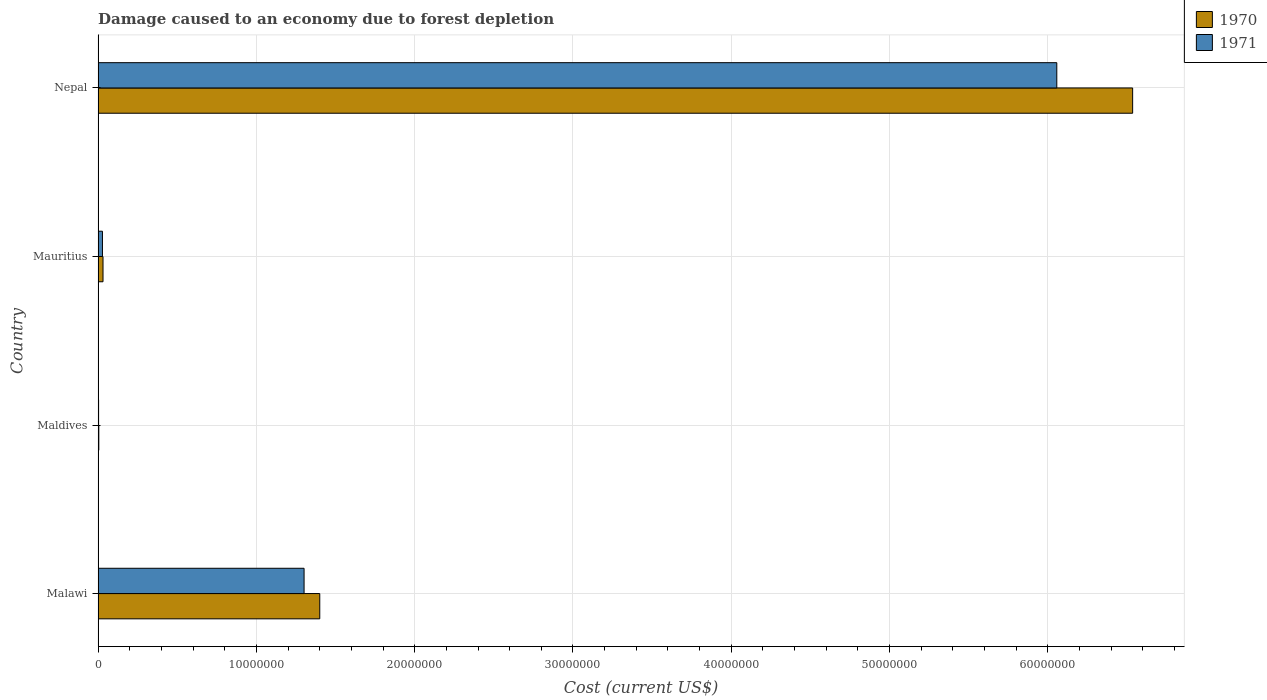How many different coloured bars are there?
Provide a short and direct response. 2. How many groups of bars are there?
Your answer should be compact. 4. Are the number of bars per tick equal to the number of legend labels?
Offer a very short reply. Yes. How many bars are there on the 4th tick from the top?
Your answer should be compact. 2. How many bars are there on the 3rd tick from the bottom?
Your answer should be very brief. 2. What is the label of the 4th group of bars from the top?
Ensure brevity in your answer.  Malawi. What is the cost of damage caused due to forest depletion in 1971 in Mauritius?
Keep it short and to the point. 2.78e+05. Across all countries, what is the maximum cost of damage caused due to forest depletion in 1971?
Offer a terse response. 6.06e+07. Across all countries, what is the minimum cost of damage caused due to forest depletion in 1971?
Your response must be concise. 3.48e+04. In which country was the cost of damage caused due to forest depletion in 1970 maximum?
Offer a terse response. Nepal. In which country was the cost of damage caused due to forest depletion in 1971 minimum?
Your answer should be very brief. Maldives. What is the total cost of damage caused due to forest depletion in 1971 in the graph?
Offer a terse response. 7.39e+07. What is the difference between the cost of damage caused due to forest depletion in 1971 in Mauritius and that in Nepal?
Offer a very short reply. -6.03e+07. What is the difference between the cost of damage caused due to forest depletion in 1971 in Nepal and the cost of damage caused due to forest depletion in 1970 in Malawi?
Your response must be concise. 4.66e+07. What is the average cost of damage caused due to forest depletion in 1971 per country?
Offer a very short reply. 1.85e+07. What is the difference between the cost of damage caused due to forest depletion in 1970 and cost of damage caused due to forest depletion in 1971 in Mauritius?
Your answer should be compact. 3.52e+04. In how many countries, is the cost of damage caused due to forest depletion in 1971 greater than 66000000 US$?
Give a very brief answer. 0. What is the ratio of the cost of damage caused due to forest depletion in 1970 in Malawi to that in Nepal?
Make the answer very short. 0.21. Is the cost of damage caused due to forest depletion in 1971 in Malawi less than that in Nepal?
Offer a very short reply. Yes. Is the difference between the cost of damage caused due to forest depletion in 1970 in Mauritius and Nepal greater than the difference between the cost of damage caused due to forest depletion in 1971 in Mauritius and Nepal?
Offer a very short reply. No. What is the difference between the highest and the second highest cost of damage caused due to forest depletion in 1971?
Give a very brief answer. 4.75e+07. What is the difference between the highest and the lowest cost of damage caused due to forest depletion in 1970?
Your response must be concise. 6.53e+07. In how many countries, is the cost of damage caused due to forest depletion in 1971 greater than the average cost of damage caused due to forest depletion in 1971 taken over all countries?
Offer a terse response. 1. Is the sum of the cost of damage caused due to forest depletion in 1971 in Malawi and Nepal greater than the maximum cost of damage caused due to forest depletion in 1970 across all countries?
Ensure brevity in your answer.  Yes. What does the 2nd bar from the top in Mauritius represents?
Your answer should be very brief. 1970. How many countries are there in the graph?
Your response must be concise. 4. What is the difference between two consecutive major ticks on the X-axis?
Give a very brief answer. 1.00e+07. Are the values on the major ticks of X-axis written in scientific E-notation?
Your answer should be very brief. No. Where does the legend appear in the graph?
Your answer should be very brief. Top right. What is the title of the graph?
Provide a succinct answer. Damage caused to an economy due to forest depletion. Does "1975" appear as one of the legend labels in the graph?
Offer a very short reply. No. What is the label or title of the X-axis?
Your answer should be very brief. Cost (current US$). What is the Cost (current US$) of 1970 in Malawi?
Ensure brevity in your answer.  1.40e+07. What is the Cost (current US$) of 1971 in Malawi?
Your answer should be compact. 1.30e+07. What is the Cost (current US$) of 1970 in Maldives?
Offer a very short reply. 4.86e+04. What is the Cost (current US$) in 1971 in Maldives?
Provide a short and direct response. 3.48e+04. What is the Cost (current US$) of 1970 in Mauritius?
Give a very brief answer. 3.14e+05. What is the Cost (current US$) in 1971 in Mauritius?
Offer a very short reply. 2.78e+05. What is the Cost (current US$) in 1970 in Nepal?
Ensure brevity in your answer.  6.54e+07. What is the Cost (current US$) of 1971 in Nepal?
Keep it short and to the point. 6.06e+07. Across all countries, what is the maximum Cost (current US$) of 1970?
Provide a short and direct response. 6.54e+07. Across all countries, what is the maximum Cost (current US$) in 1971?
Make the answer very short. 6.06e+07. Across all countries, what is the minimum Cost (current US$) in 1970?
Keep it short and to the point. 4.86e+04. Across all countries, what is the minimum Cost (current US$) in 1971?
Your answer should be compact. 3.48e+04. What is the total Cost (current US$) in 1970 in the graph?
Offer a terse response. 7.97e+07. What is the total Cost (current US$) in 1971 in the graph?
Give a very brief answer. 7.39e+07. What is the difference between the Cost (current US$) in 1970 in Malawi and that in Maldives?
Provide a short and direct response. 1.40e+07. What is the difference between the Cost (current US$) of 1971 in Malawi and that in Maldives?
Offer a terse response. 1.30e+07. What is the difference between the Cost (current US$) of 1970 in Malawi and that in Mauritius?
Keep it short and to the point. 1.37e+07. What is the difference between the Cost (current US$) in 1971 in Malawi and that in Mauritius?
Offer a terse response. 1.27e+07. What is the difference between the Cost (current US$) in 1970 in Malawi and that in Nepal?
Give a very brief answer. -5.13e+07. What is the difference between the Cost (current US$) in 1971 in Malawi and that in Nepal?
Ensure brevity in your answer.  -4.75e+07. What is the difference between the Cost (current US$) in 1970 in Maldives and that in Mauritius?
Ensure brevity in your answer.  -2.65e+05. What is the difference between the Cost (current US$) of 1971 in Maldives and that in Mauritius?
Offer a very short reply. -2.44e+05. What is the difference between the Cost (current US$) in 1970 in Maldives and that in Nepal?
Offer a very short reply. -6.53e+07. What is the difference between the Cost (current US$) in 1971 in Maldives and that in Nepal?
Your response must be concise. -6.05e+07. What is the difference between the Cost (current US$) in 1970 in Mauritius and that in Nepal?
Offer a very short reply. -6.50e+07. What is the difference between the Cost (current US$) of 1971 in Mauritius and that in Nepal?
Offer a terse response. -6.03e+07. What is the difference between the Cost (current US$) of 1970 in Malawi and the Cost (current US$) of 1971 in Maldives?
Give a very brief answer. 1.40e+07. What is the difference between the Cost (current US$) of 1970 in Malawi and the Cost (current US$) of 1971 in Mauritius?
Provide a succinct answer. 1.37e+07. What is the difference between the Cost (current US$) in 1970 in Malawi and the Cost (current US$) in 1971 in Nepal?
Offer a terse response. -4.66e+07. What is the difference between the Cost (current US$) in 1970 in Maldives and the Cost (current US$) in 1971 in Mauritius?
Provide a succinct answer. -2.30e+05. What is the difference between the Cost (current US$) in 1970 in Maldives and the Cost (current US$) in 1971 in Nepal?
Ensure brevity in your answer.  -6.05e+07. What is the difference between the Cost (current US$) of 1970 in Mauritius and the Cost (current US$) of 1971 in Nepal?
Give a very brief answer. -6.02e+07. What is the average Cost (current US$) in 1970 per country?
Your response must be concise. 1.99e+07. What is the average Cost (current US$) in 1971 per country?
Ensure brevity in your answer.  1.85e+07. What is the difference between the Cost (current US$) of 1970 and Cost (current US$) of 1971 in Malawi?
Give a very brief answer. 9.91e+05. What is the difference between the Cost (current US$) in 1970 and Cost (current US$) in 1971 in Maldives?
Your answer should be very brief. 1.39e+04. What is the difference between the Cost (current US$) of 1970 and Cost (current US$) of 1971 in Mauritius?
Offer a very short reply. 3.52e+04. What is the difference between the Cost (current US$) of 1970 and Cost (current US$) of 1971 in Nepal?
Offer a terse response. 4.79e+06. What is the ratio of the Cost (current US$) in 1970 in Malawi to that in Maldives?
Offer a terse response. 287.9. What is the ratio of the Cost (current US$) of 1971 in Malawi to that in Maldives?
Offer a terse response. 374.14. What is the ratio of the Cost (current US$) in 1970 in Malawi to that in Mauritius?
Provide a short and direct response. 44.67. What is the ratio of the Cost (current US$) in 1971 in Malawi to that in Mauritius?
Your response must be concise. 46.76. What is the ratio of the Cost (current US$) of 1970 in Malawi to that in Nepal?
Ensure brevity in your answer.  0.21. What is the ratio of the Cost (current US$) in 1971 in Malawi to that in Nepal?
Make the answer very short. 0.21. What is the ratio of the Cost (current US$) in 1970 in Maldives to that in Mauritius?
Provide a succinct answer. 0.16. What is the ratio of the Cost (current US$) in 1970 in Maldives to that in Nepal?
Offer a very short reply. 0. What is the ratio of the Cost (current US$) in 1971 in Maldives to that in Nepal?
Provide a short and direct response. 0. What is the ratio of the Cost (current US$) in 1970 in Mauritius to that in Nepal?
Ensure brevity in your answer.  0. What is the ratio of the Cost (current US$) in 1971 in Mauritius to that in Nepal?
Make the answer very short. 0. What is the difference between the highest and the second highest Cost (current US$) of 1970?
Offer a very short reply. 5.13e+07. What is the difference between the highest and the second highest Cost (current US$) of 1971?
Offer a terse response. 4.75e+07. What is the difference between the highest and the lowest Cost (current US$) in 1970?
Make the answer very short. 6.53e+07. What is the difference between the highest and the lowest Cost (current US$) in 1971?
Your response must be concise. 6.05e+07. 